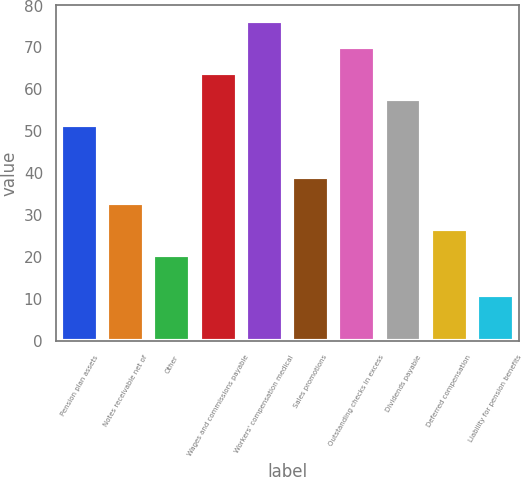Convert chart. <chart><loc_0><loc_0><loc_500><loc_500><bar_chart><fcel>Pension plan assets<fcel>Notes receivable net of<fcel>Other<fcel>Wages and commissions payable<fcel>Workers' compensation medical<fcel>Sales promotions<fcel>Outstanding checks in excess<fcel>Dividends payable<fcel>Deferred compensation<fcel>Liability for pension benefits<nl><fcel>51.5<fcel>32.96<fcel>20.6<fcel>63.86<fcel>76.22<fcel>39.14<fcel>70.04<fcel>57.68<fcel>26.78<fcel>11<nl></chart> 